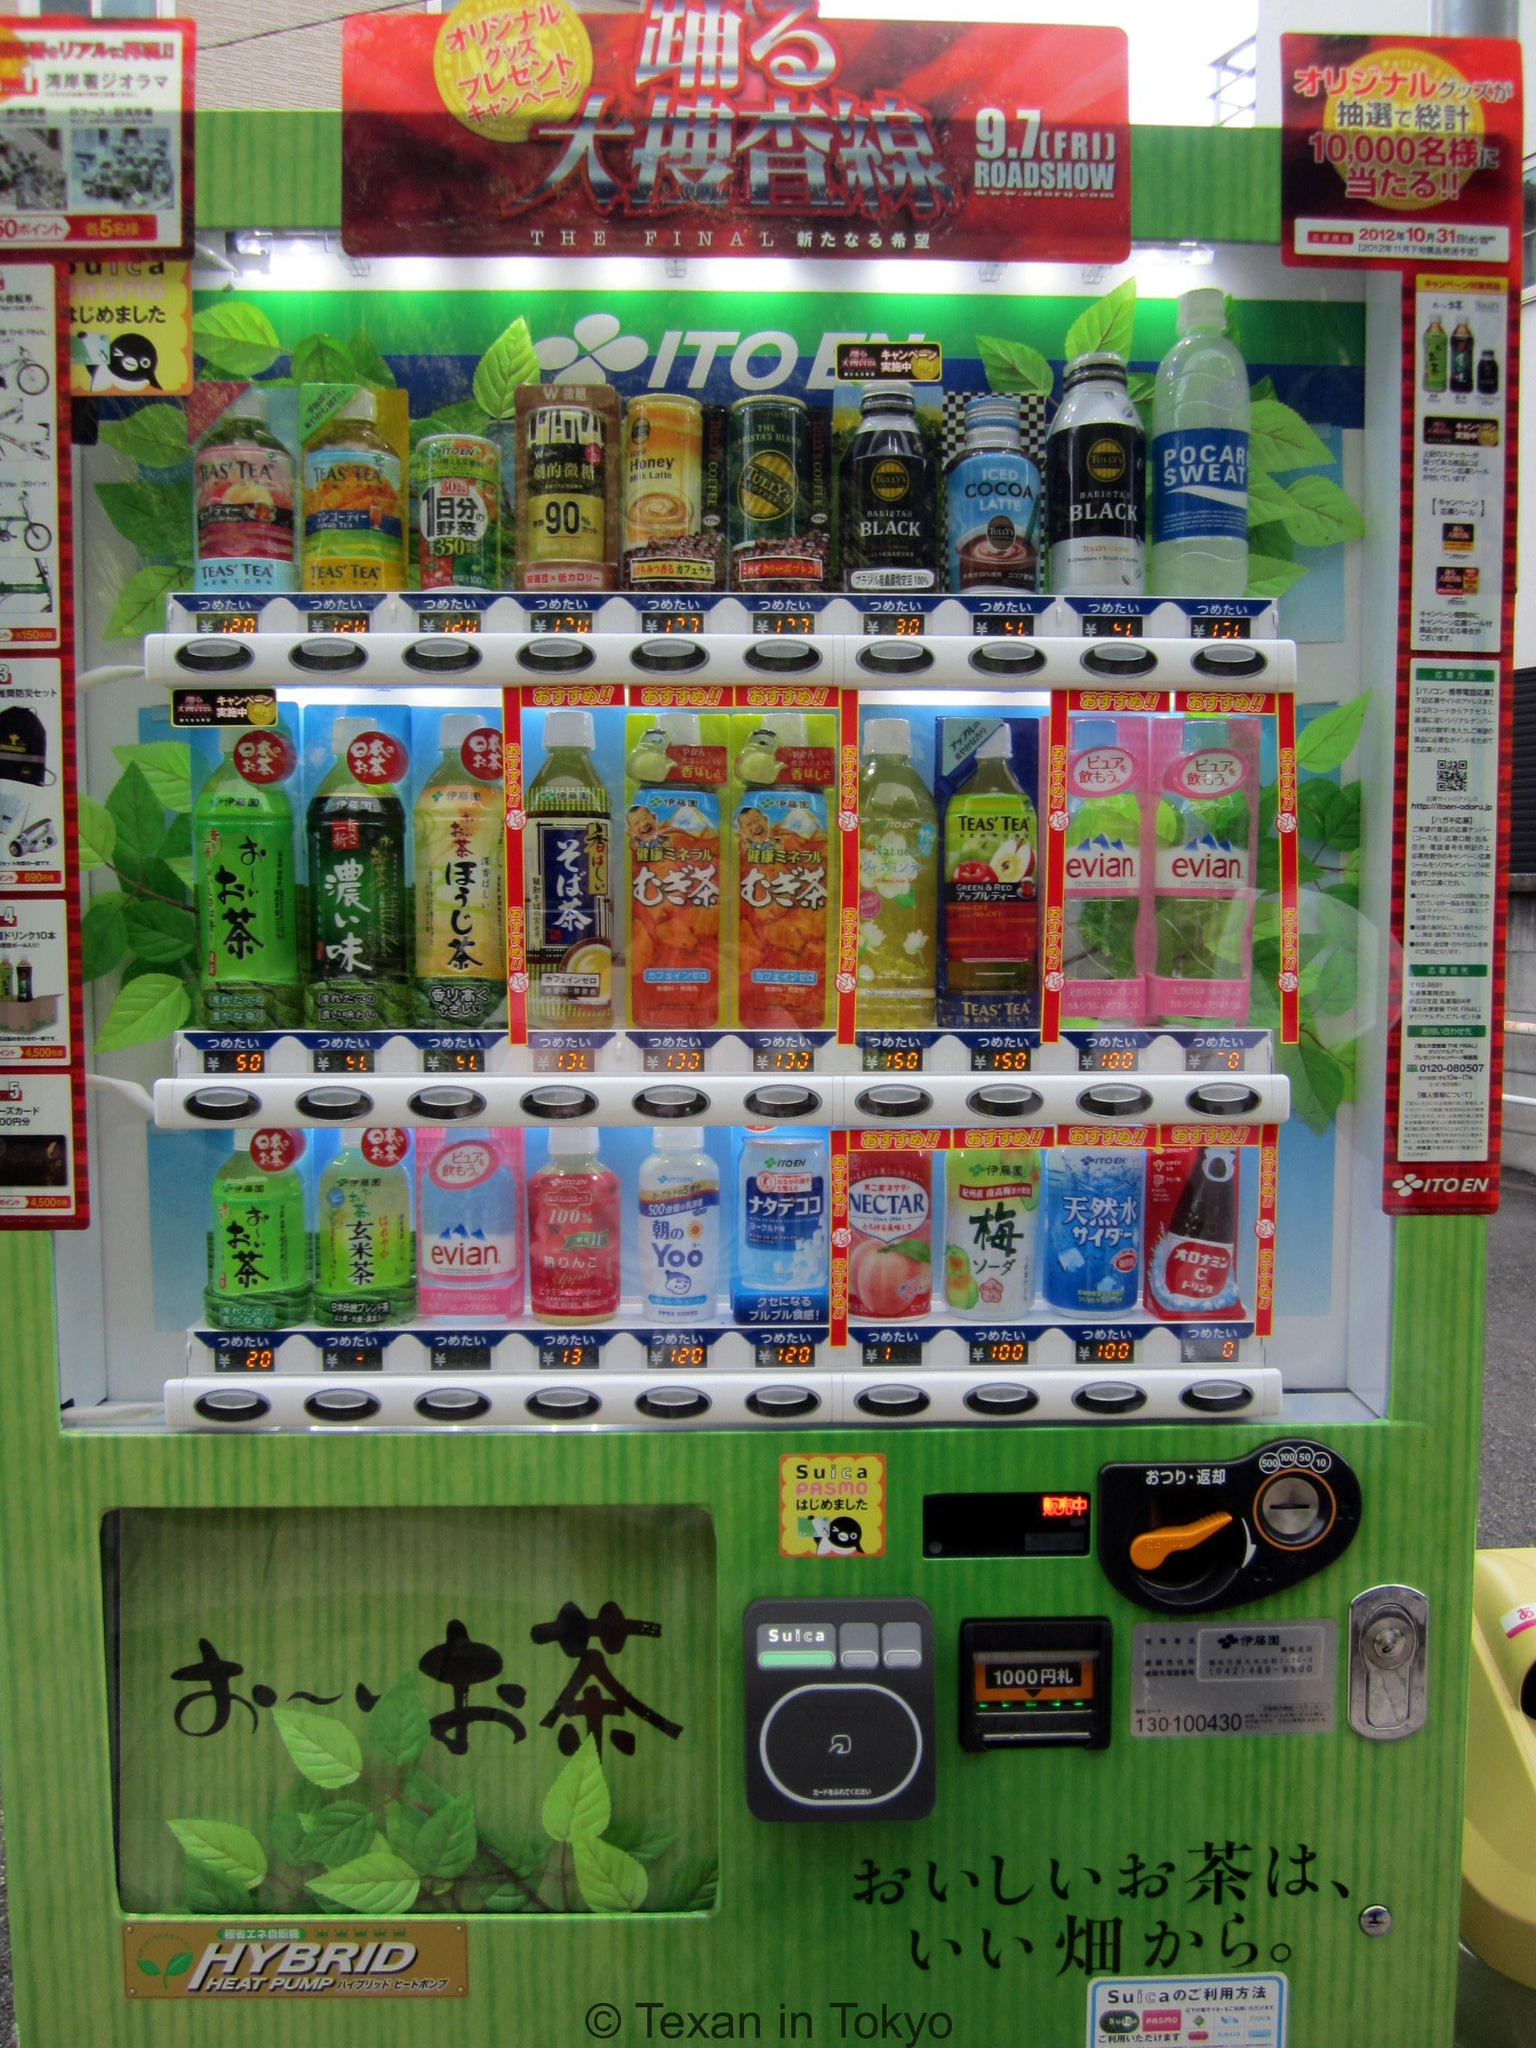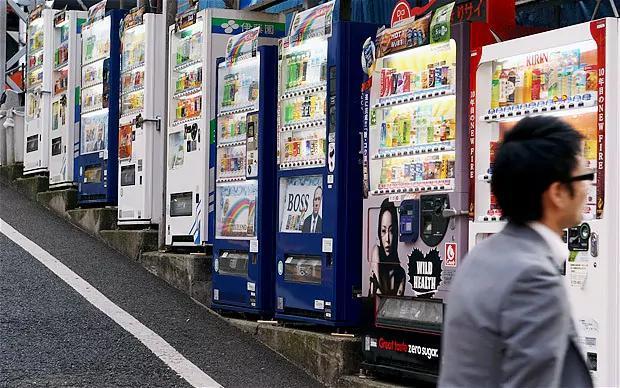The first image is the image on the left, the second image is the image on the right. Analyze the images presented: Is the assertion "There are no more than five machines." valid? Answer yes or no. No. The first image is the image on the left, the second image is the image on the right. Given the left and right images, does the statement "There is a row of red, white, and blue vending machines with pavement in front of them." hold true? Answer yes or no. Yes. 